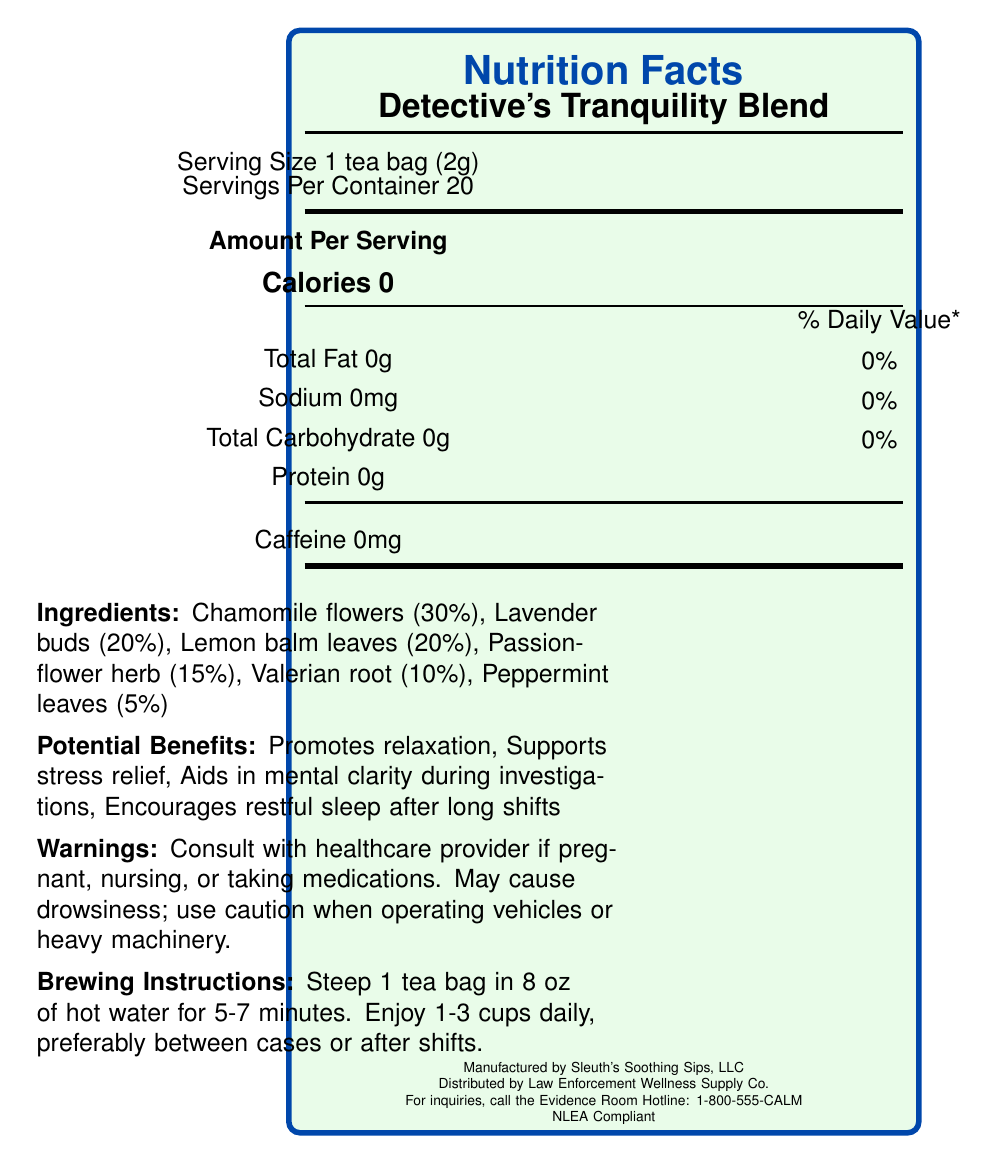what is the serving size of Detective's Tranquility Blend? The serving size is listed at the top of the nutrition facts label, indicating that one serving is equivalent to 1 tea bag, which weighs 2 grams.
Answer: 1 tea bag (2g) how many servings are there per container? The document states "Servings Per Container 20" near the top of the label, just below the serving size information.
Answer: 20 how many calories are there per serving? The label specifies "Calories 0" under the "Amount Per Serving" section.
Answer: 0 calories what percentage of the herb blend is made up of valerian root? The ingredients section of the document lists the composition of the herb blend, showing that valerian root makes up 10% of the blend.
Answer: 10% what are the brewing instructions for this tea? The brewing instructions are provided under "Brewing Instructions."
Answer: Steep 1 tea bag in 8 oz of hot water for 5-7 minutes. Enjoy 1-3 cups daily, preferably between cases or after shifts. what is the total fat content per serving? A. 0g B. 0.5g C. 1g D. 2g The label states "Total Fat 0g" under the section detailing nutritional values.
Answer: A. 0g which of the following is not a potential benefit listed for this tea? 1. Supports stress relief 2. Promotes relaxation 3. Alleviates headaches 4. Aids in mental clarity during investigations The document lists the potential benefits, which include promoting relaxation, supporting stress relief, aiding in mental clarity during investigations, and encouraging restful sleep, but not alleviating headaches.
Answer: 3. Alleviates headaches is this tea caffeinated? The document specifies "Caffeine 0mg," indicating that the tea is not caffeinated.
Answer: No what is the main idea of the document? The document contains comprehensive information about the tea, including nutritional and ingredient details, as well as usage instructions and manufacturer information.
Answer: The document provides the nutrition facts, ingredients, potential benefits, warnings, brewing instructions, storage recommendations, and contact information for Detective's Tranquility Blend, a stress-relieving herbal tea popular among detectives. who is the manufacturer of Detective's Tranquility Blend? The manufacturer's name is found at the bottom of the document, where it states "Manufactured by Sleuth's Soothing Sips, LLC."
Answer: Sleuth's Soothing Sips, LLC how much sodium is in each serving? The section on sodium content specifies "Sodium 0mg," indicating that each serving contains no sodium.
Answer: 0mg which ingredient has the highest proportion in the herb blend? According to the herb blend composition, chamomile flowers constitute 30%, which is the highest proportion among the listed ingredients.
Answer: Chamomile flowers what company distributes Detective's Tranquility Blend? The distributor information is provided at the bottom of the document, stating that the tea is distributed by Law Enforcement Wellness Supply Co.
Answer: Law Enforcement Wellness Supply Co. can I drink this tea while operating heavy machinery without any issues? The warning section advises that the tea may cause drowsiness and suggests using caution when operating vehicles or heavy machinery.
Answer: No what is the contact number for inquiries? The contact number for inquiries is listed at the bottom of the document as "For inquiries, call the Evidence Room Hotline: 1-800-555-CALM."
Answer: 1-800-555-CALM what is the daily value percentage for total carbohydrate? The nutrition facts section lists "Total Carbohydrate 0g" and "0%" next to it, indicating the daily value percentage.
Answer: 0% what steps should be followed to store the tea properly? The storage recommendations are provided under the "Storage" section of the document.
Answer: Store in a cool, dry place away from direct sunlight and strong odors to preserve evidence-grade freshness. does this tea contain sugar? The document does not mention sugar content explicitly. It only lists total carbohydrates as 0g, so whether any trace amounts of sugar are present cannot be determined from the provided information.
Answer: Not enough information 